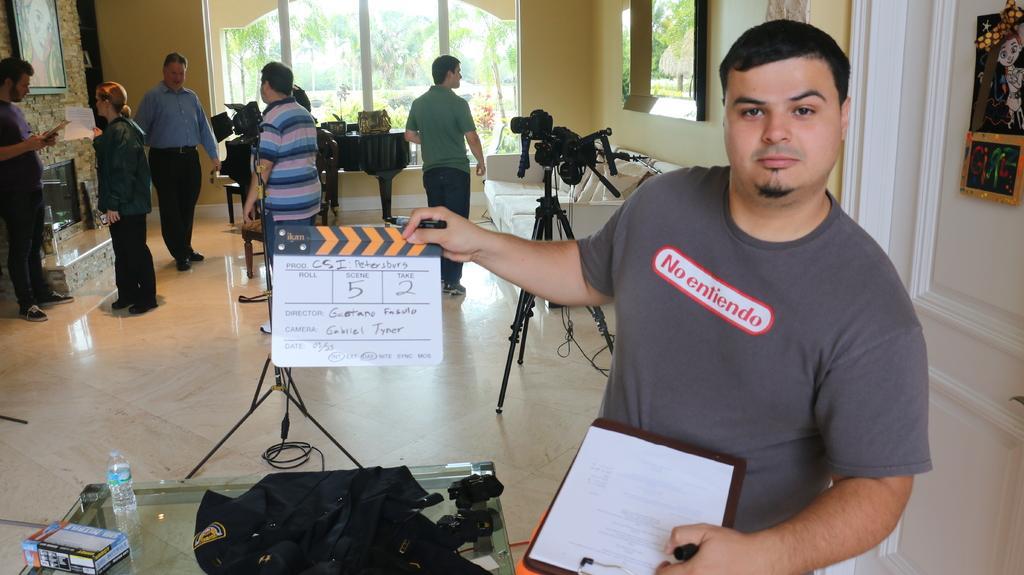Describe this image in one or two sentences. In this image we can see persons standing on the floor, windows, camera, tripod, papers, plank, cables, disposal bottle, table, books and a mantelpiece. 